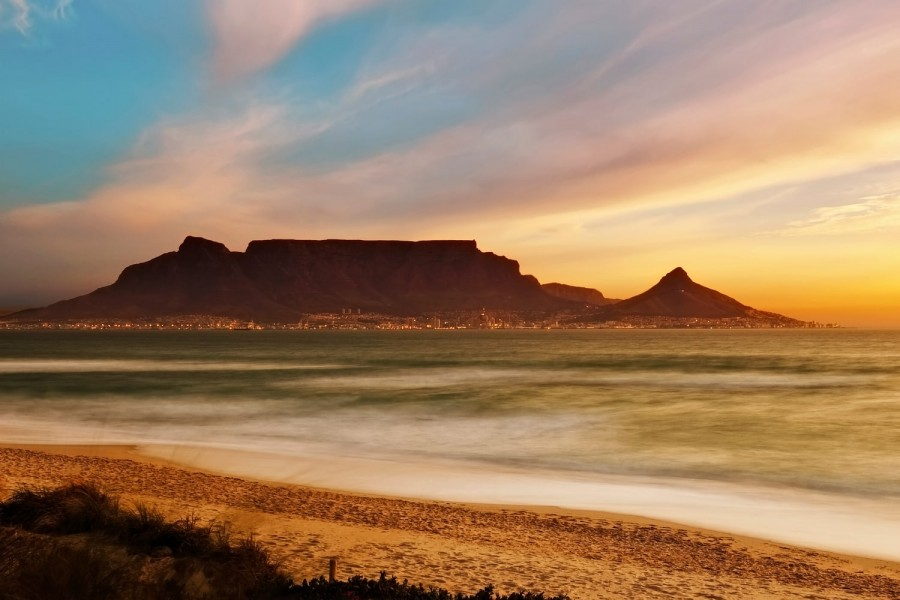If someone was to paint this scene, what kind of artistic style do you think would best capture its essence and why? To best capture the essence of this serene yet dynamic scene, an artist might choose the Impressionist style. This style, characterized by vivid, expressive brush strokes, and a focus on the play of light, would beautifully portray the vibrant hues of the sunset and the shimmering water. The use of light and shadow in Impressionism would bring the flat-topped Table Mountain's silhouette to life, while the city lights at its base could be depicted with dabs of bright, contrasting colors, creating a lively touch in the otherwise tranquil setting. The beach's smooth sand and the blurring of the waves, a result of long exposure in the photograph, could be captured through gentle, flowing strokes, resonating with the overall calming atmosphere of the scene.  What if the waves in this image were actually solid glass? Describe how this would alter the scene. If the waves in the image were transformed into solid glass, the scene would take on a surreal, almost otherworldly quality. The once flowing, dynamic water would be frozen in time, each wave crest and trough perfectly preserved as if sculpted by an artist. The light from the sunset would refract and scatter through the transparent glass, casting prismatic light displays across the beach and onto the base of Table Mountain. Footprints on the sand would contrast starkly with the clear, crystalline forms of the waves. The city lights at the mountain's base would reflect off the glass, creating an interplay of natural and artificial light that would transform the entire landscape into a surreal, dreamlike tableau. Visitors would walk gingerly around these solid forms, marveling at the transformation of a familiar, fluid element into something almost magical and wholly unexpected. 